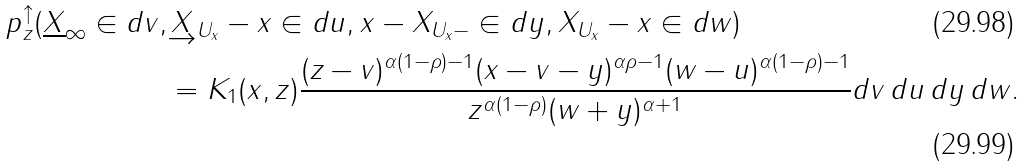<formula> <loc_0><loc_0><loc_500><loc_500>\ p ^ { \uparrow } _ { z } ( \underline { X } _ { \infty } \in d v , & \underrightarrow { X } _ { U _ { x } } - x \in d u , x - X _ { U _ { x } - } \in d y , X _ { U _ { x } } - x \in d w ) \\ & = K _ { 1 } ( x , z ) \frac { ( z - v ) ^ { \alpha ( 1 - \rho ) - 1 } ( x - v - y ) ^ { \alpha \rho - 1 } ( w - u ) ^ { \alpha ( 1 - \rho ) - 1 } } { z ^ { \alpha ( 1 - \rho ) } ( w + y ) ^ { \alpha + 1 } } d v \, d u \, d y \, d w .</formula> 